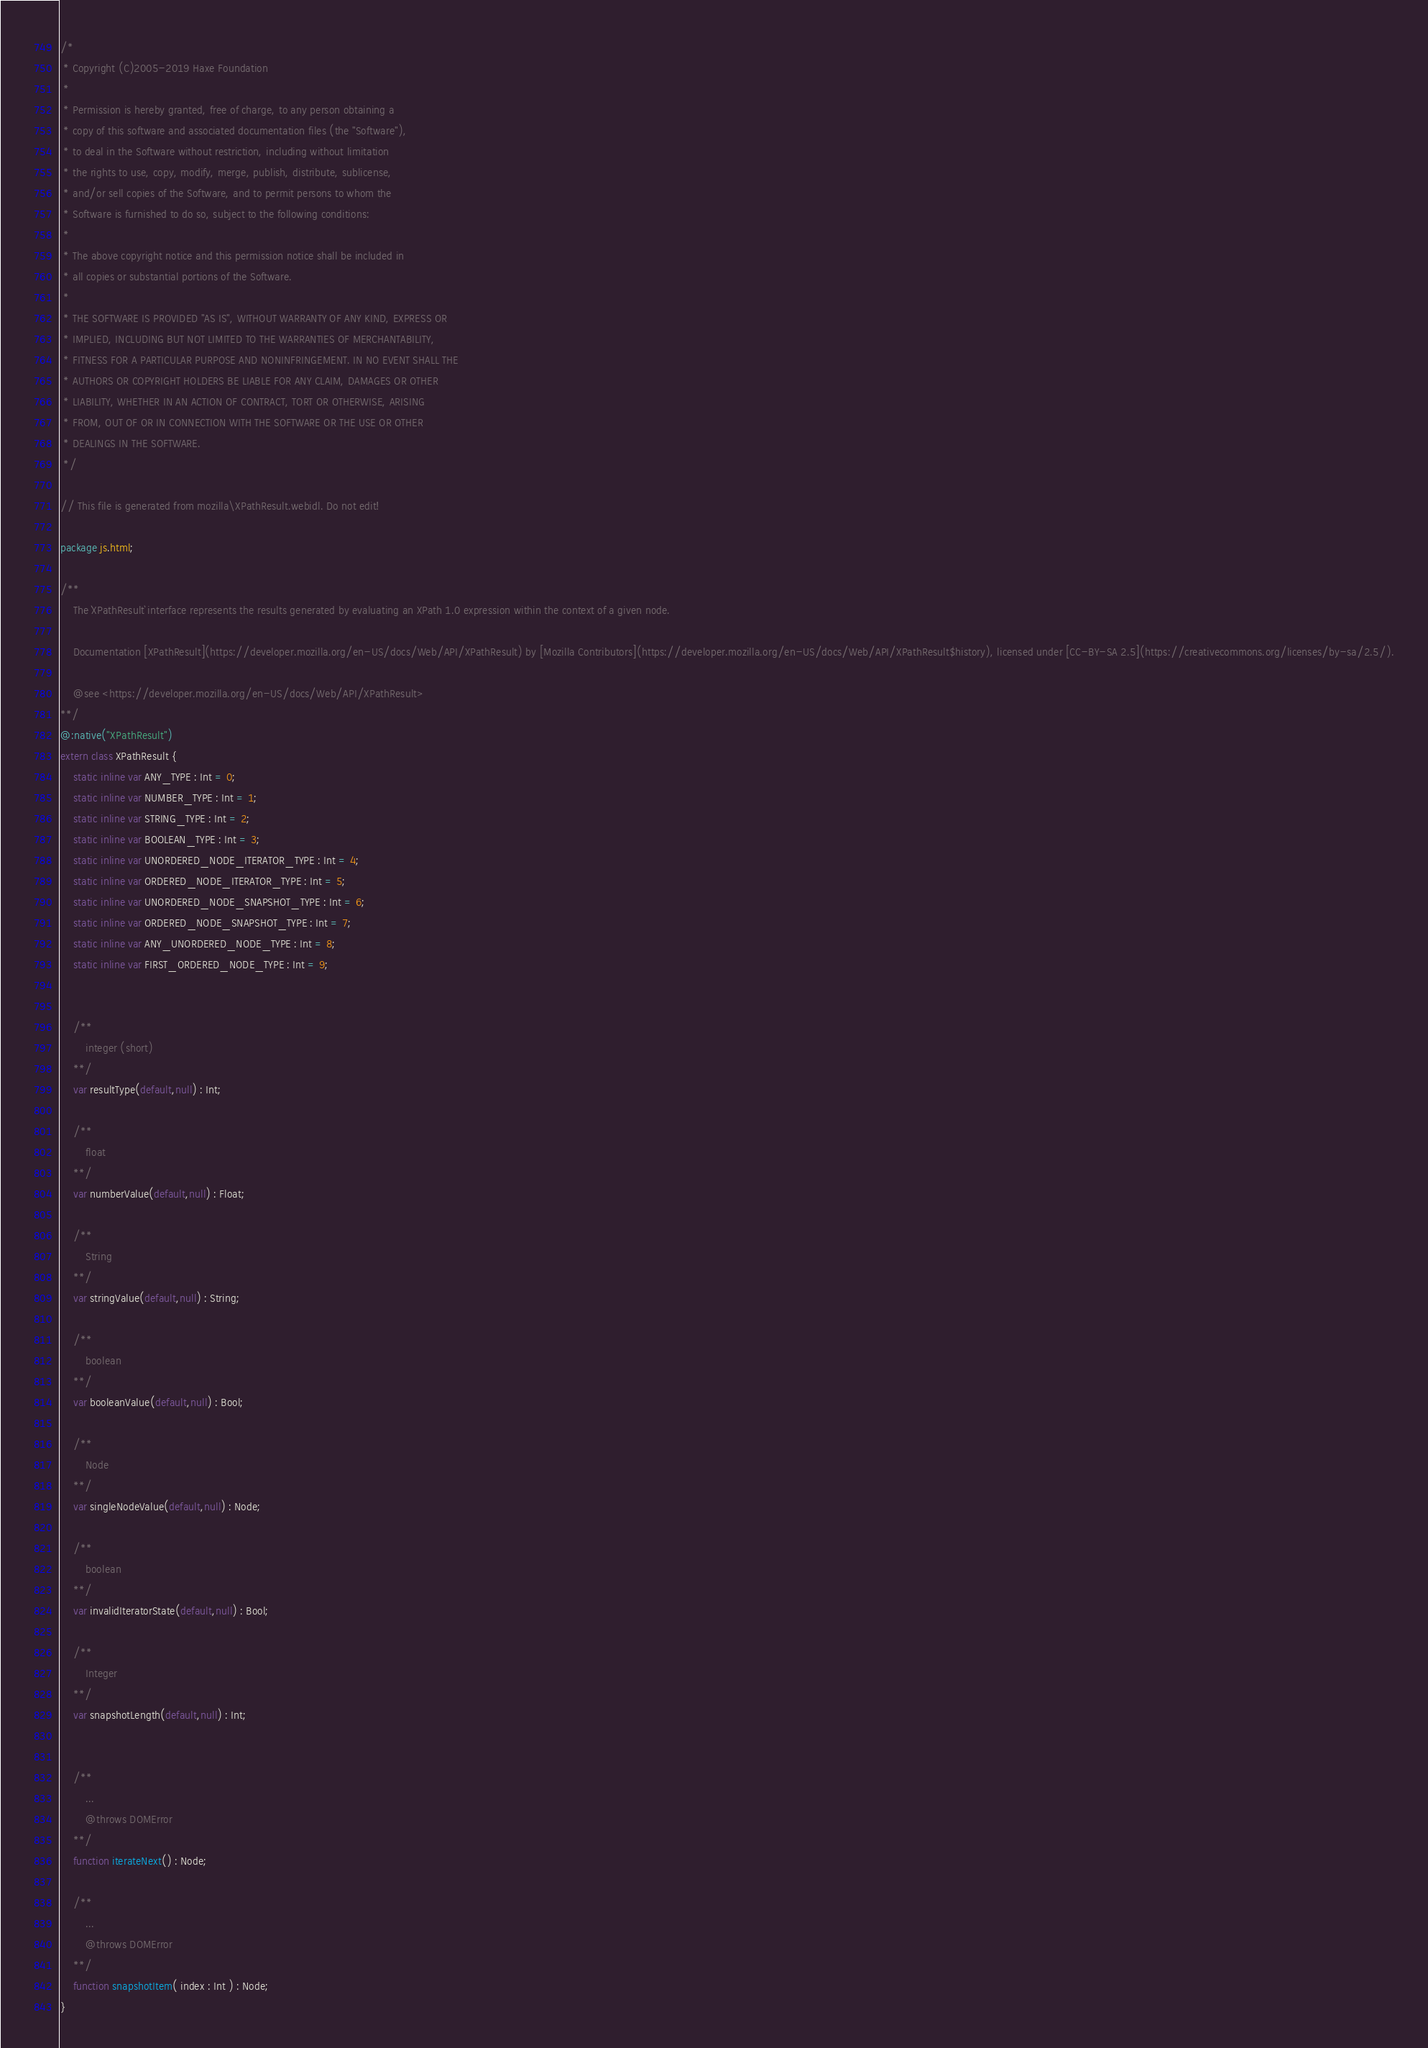<code> <loc_0><loc_0><loc_500><loc_500><_Haxe_>/*
 * Copyright (C)2005-2019 Haxe Foundation
 *
 * Permission is hereby granted, free of charge, to any person obtaining a
 * copy of this software and associated documentation files (the "Software"),
 * to deal in the Software without restriction, including without limitation
 * the rights to use, copy, modify, merge, publish, distribute, sublicense,
 * and/or sell copies of the Software, and to permit persons to whom the
 * Software is furnished to do so, subject to the following conditions:
 *
 * The above copyright notice and this permission notice shall be included in
 * all copies or substantial portions of the Software.
 *
 * THE SOFTWARE IS PROVIDED "AS IS", WITHOUT WARRANTY OF ANY KIND, EXPRESS OR
 * IMPLIED, INCLUDING BUT NOT LIMITED TO THE WARRANTIES OF MERCHANTABILITY,
 * FITNESS FOR A PARTICULAR PURPOSE AND NONINFRINGEMENT. IN NO EVENT SHALL THE
 * AUTHORS OR COPYRIGHT HOLDERS BE LIABLE FOR ANY CLAIM, DAMAGES OR OTHER
 * LIABILITY, WHETHER IN AN ACTION OF CONTRACT, TORT OR OTHERWISE, ARISING
 * FROM, OUT OF OR IN CONNECTION WITH THE SOFTWARE OR THE USE OR OTHER
 * DEALINGS IN THE SOFTWARE.
 */

// This file is generated from mozilla\XPathResult.webidl. Do not edit!

package js.html;

/**
	The `XPathResult` interface represents the results generated by evaluating an XPath 1.0 expression within the context of a given node.

	Documentation [XPathResult](https://developer.mozilla.org/en-US/docs/Web/API/XPathResult) by [Mozilla Contributors](https://developer.mozilla.org/en-US/docs/Web/API/XPathResult$history), licensed under [CC-BY-SA 2.5](https://creativecommons.org/licenses/by-sa/2.5/).

	@see <https://developer.mozilla.org/en-US/docs/Web/API/XPathResult>
**/
@:native("XPathResult")
extern class XPathResult {
	static inline var ANY_TYPE : Int = 0;
	static inline var NUMBER_TYPE : Int = 1;
	static inline var STRING_TYPE : Int = 2;
	static inline var BOOLEAN_TYPE : Int = 3;
	static inline var UNORDERED_NODE_ITERATOR_TYPE : Int = 4;
	static inline var ORDERED_NODE_ITERATOR_TYPE : Int = 5;
	static inline var UNORDERED_NODE_SNAPSHOT_TYPE : Int = 6;
	static inline var ORDERED_NODE_SNAPSHOT_TYPE : Int = 7;
	static inline var ANY_UNORDERED_NODE_TYPE : Int = 8;
	static inline var FIRST_ORDERED_NODE_TYPE : Int = 9;
	
	
	/**
		integer (short)
	**/
	var resultType(default,null) : Int;
	
	/**
		float
	**/
	var numberValue(default,null) : Float;
	
	/**
		String
	**/
	var stringValue(default,null) : String;
	
	/**
		boolean
	**/
	var booleanValue(default,null) : Bool;
	
	/**
		Node
	**/
	var singleNodeValue(default,null) : Node;
	
	/**
		boolean
	**/
	var invalidIteratorState(default,null) : Bool;
	
	/**
		Integer
	**/
	var snapshotLength(default,null) : Int;
	
	
	/**
		...
		@throws DOMError
	**/
	function iterateNext() : Node;
	
	/**
		...
		@throws DOMError
	**/
	function snapshotItem( index : Int ) : Node;
}</code> 